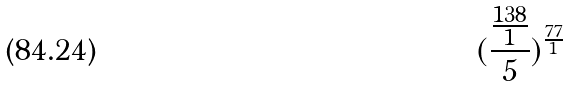Convert formula to latex. <formula><loc_0><loc_0><loc_500><loc_500>( \frac { \frac { 1 3 8 } { 1 } } { 5 } ) ^ { \frac { 7 7 } { 1 } }</formula> 